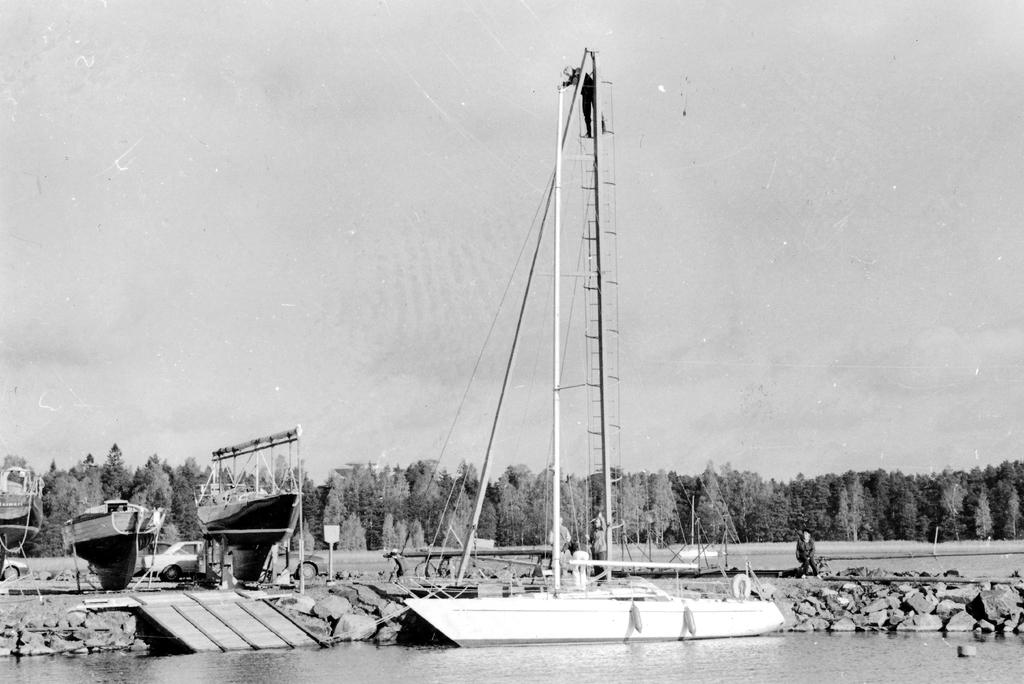What is the main subject of the image? The main subject of the image is a boat on the water. What other objects or features can be seen in the image? There are rocks, poles, people, vehicles, trees, and some objects visible in the image. What is the background of the image? The sky is visible in the background of the image. What type of pear is being used as a prop in the image? There is no pear present in the image. What is the edge of the image used for? The edge of the image is not a physical object or feature in the scene; it is simply the boundary of the photograph. 